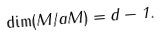<formula> <loc_0><loc_0><loc_500><loc_500>\dim ( M / a M ) = d - 1 .</formula> 